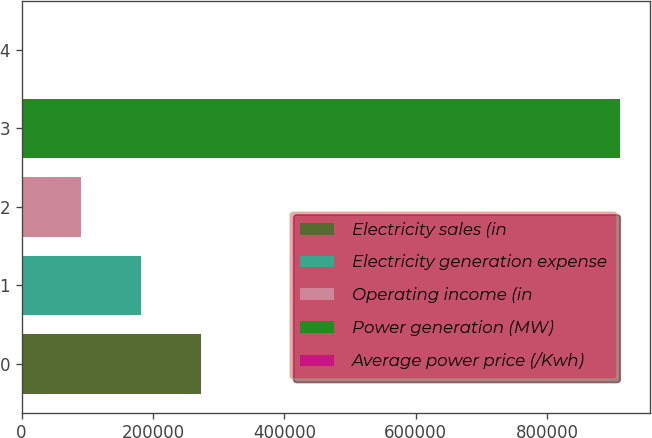Convert chart to OTSL. <chart><loc_0><loc_0><loc_500><loc_500><bar_chart><fcel>Electricity sales (in<fcel>Electricity generation expense<fcel>Operating income (in<fcel>Power generation (MW)<fcel>Average power price (/Kwh)<nl><fcel>273549<fcel>182366<fcel>91183.1<fcel>911830<fcel>0.08<nl></chart> 